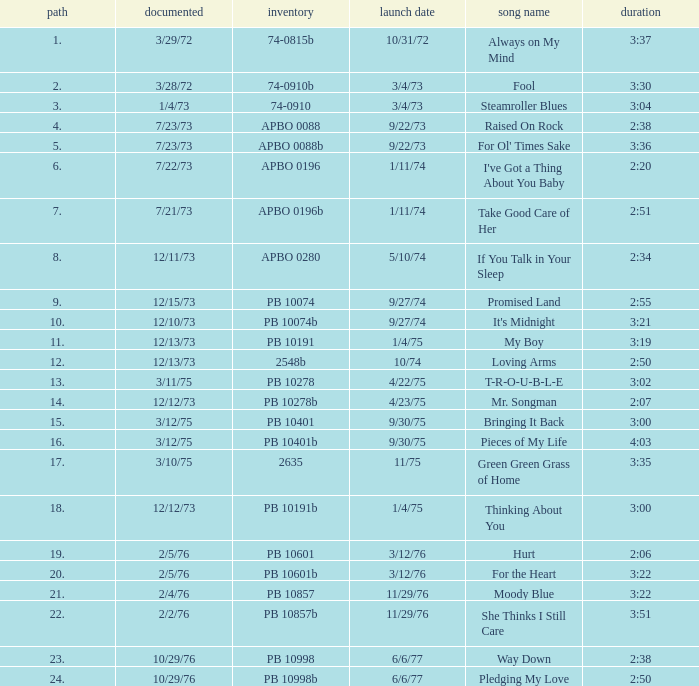Tell me the release date record on 10/29/76 and a time on 2:50 6/6/77. 